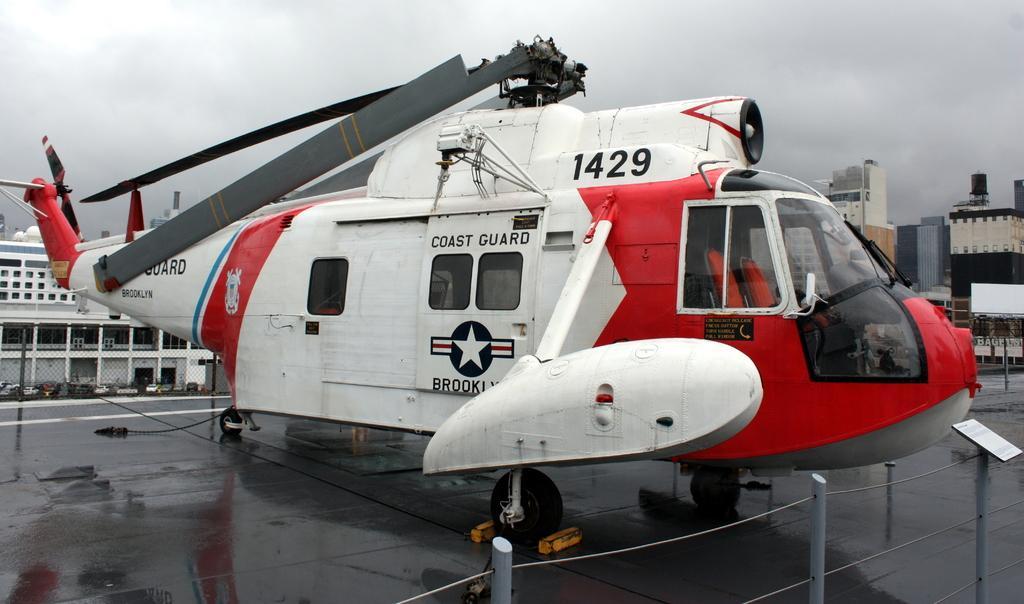Please provide a concise description of this image. In this image we can see a helicopter, iron rods and a board in front of the helicopter and in the background there are a few buildings and vehicles. 